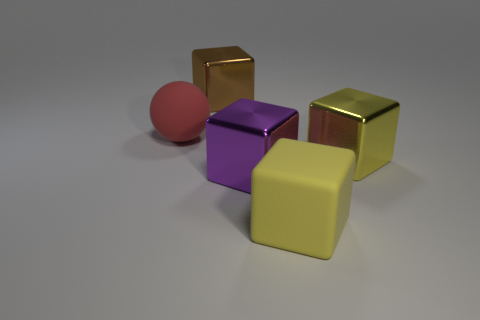What number of things are both to the right of the large red ball and on the left side of the large matte cube?
Provide a succinct answer. 2. There is a large purple metal thing in front of the large shiny thing that is behind the ball; are there any big purple metallic things on the left side of it?
Offer a very short reply. No. There is a matte object that is the same size as the ball; what shape is it?
Your answer should be very brief. Cube. Is there a tiny matte ball that has the same color as the large rubber block?
Make the answer very short. No. Does the red thing have the same shape as the purple metallic object?
Your response must be concise. No. What number of large things are yellow objects or shiny blocks?
Your answer should be compact. 4. The other big object that is the same material as the large red object is what color?
Keep it short and to the point. Yellow. What number of large red balls are made of the same material as the red object?
Provide a short and direct response. 0. There is a rubber thing to the right of the big red ball; does it have the same size as the shiny block that is behind the yellow metal cube?
Keep it short and to the point. Yes. The object behind the big matte object that is on the left side of the large brown cube is made of what material?
Provide a succinct answer. Metal. 